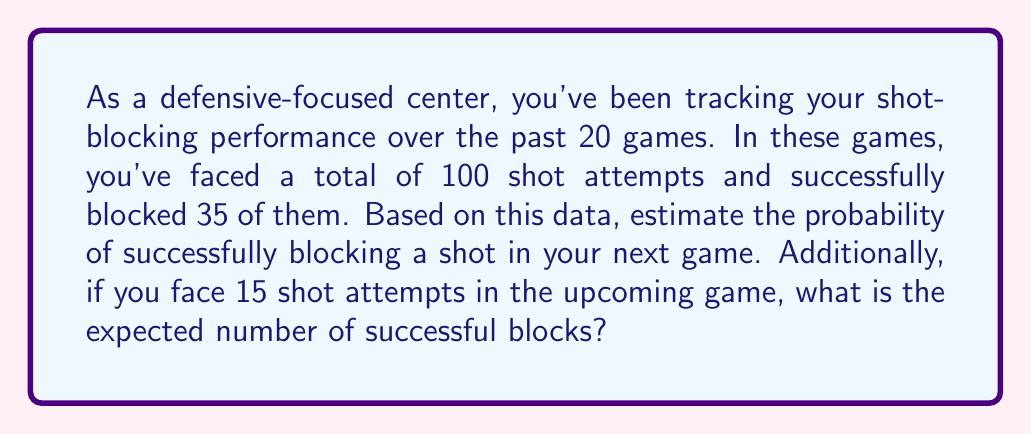Solve this math problem. To solve this problem, we'll use the concepts of probability and expected value.

1. Estimating the probability of a successful block:
   The probability of an event can be estimated by its relative frequency over a large number of trials.

   $$ P(\text{successful block}) = \frac{\text{number of successful blocks}}{\text{total number of shot attempts}} $$

   $$ P(\text{successful block}) = \frac{35}{100} = 0.35 = 35\% $$

2. Expected number of successful blocks in the next game:
   The expected value is calculated by multiplying the probability of an event by the number of trials.

   $$ E(\text{successful blocks}) = P(\text{successful block}) \times \text{number of shot attempts} $$
   
   $$ E(\text{successful blocks}) = 0.35 \times 15 = 5.25 $$

Therefore, based on your historical data, the probability of successfully blocking a shot is 35%, and you can expect to block approximately 5.25 shots in a game with 15 shot attempts.
Answer: The probability of successfully blocking a shot is 35% or 0.35. The expected number of successful blocks in a game with 15 shot attempts is 5.25. 